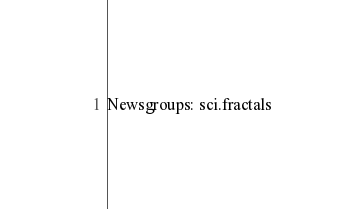Convert code to text. <code><loc_0><loc_0><loc_500><loc_500><_VisualBasic_>Newsgroups: sci.fractals</code> 